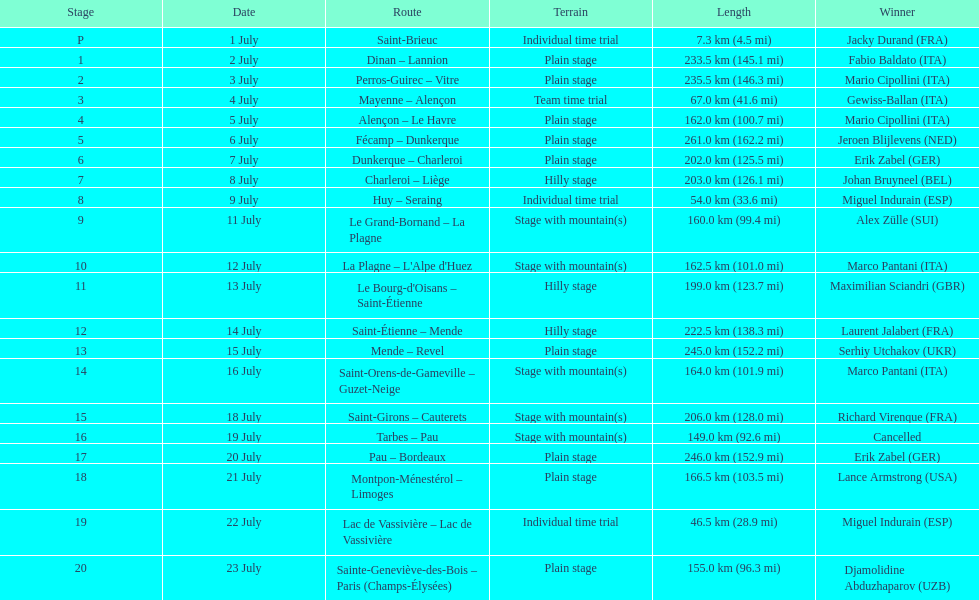Which routes were at least 100 km? Dinan - Lannion, Perros-Guirec - Vitre, Alençon - Le Havre, Fécamp - Dunkerque, Dunkerque - Charleroi, Charleroi - Liège, Le Grand-Bornand - La Plagne, La Plagne - L'Alpe d'Huez, Le Bourg-d'Oisans - Saint-Étienne, Saint-Étienne - Mende, Mende - Revel, Saint-Orens-de-Gameville - Guzet-Neige, Saint-Girons - Cauterets, Tarbes - Pau, Pau - Bordeaux, Montpon-Ménestérol - Limoges, Sainte-Geneviève-des-Bois - Paris (Champs-Élysées). 